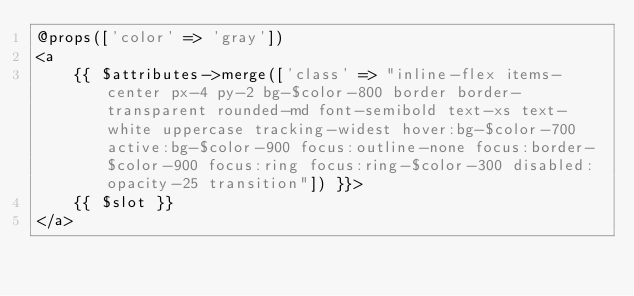Convert code to text. <code><loc_0><loc_0><loc_500><loc_500><_PHP_>@props(['color' => 'gray'])
<a
    {{ $attributes->merge(['class' => "inline-flex items-center px-4 py-2 bg-$color-800 border border-transparent rounded-md font-semibold text-xs text-white uppercase tracking-widest hover:bg-$color-700 active:bg-$color-900 focus:outline-none focus:border-$color-900 focus:ring focus:ring-$color-300 disabled:opacity-25 transition"]) }}>
    {{ $slot }}
</a>
</code> 